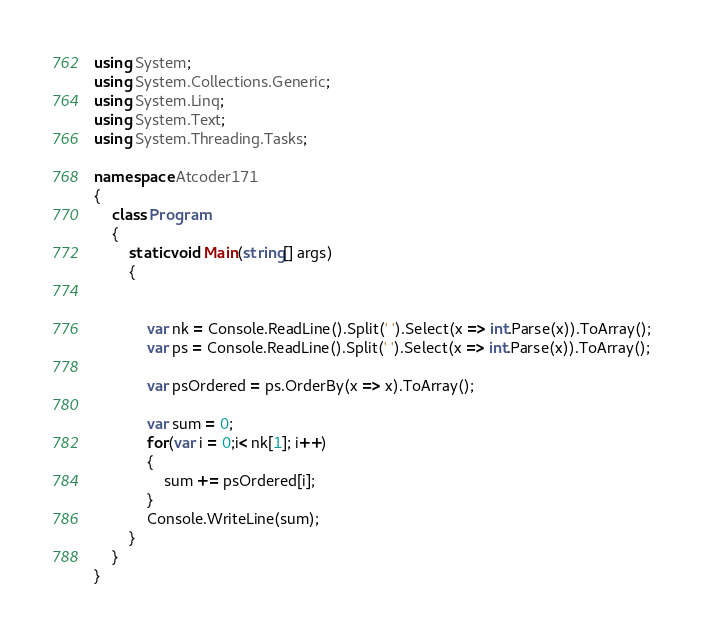Convert code to text. <code><loc_0><loc_0><loc_500><loc_500><_C#_>using System;
using System.Collections.Generic;
using System.Linq;
using System.Text;
using System.Threading.Tasks;

namespace Atcoder171
{
    class Program
    {
        static void Main(string[] args)
        {


            var nk = Console.ReadLine().Split(' ').Select(x => int.Parse(x)).ToArray();
            var ps = Console.ReadLine().Split(' ').Select(x => int.Parse(x)).ToArray();

            var psOrdered = ps.OrderBy(x => x).ToArray();

            var sum = 0;
            for(var i = 0;i< nk[1]; i++)
            {
                sum += psOrdered[i];
            }
            Console.WriteLine(sum);
        }
    }
}</code> 